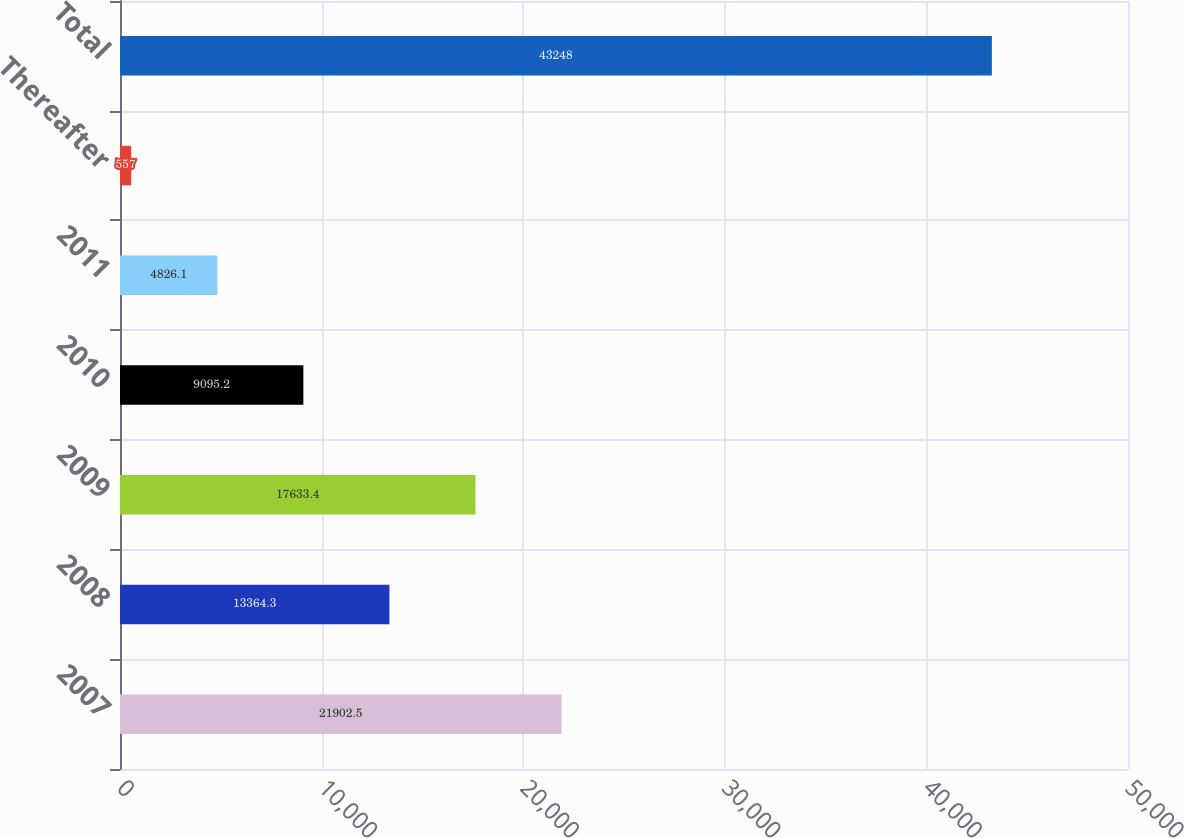<chart> <loc_0><loc_0><loc_500><loc_500><bar_chart><fcel>2007<fcel>2008<fcel>2009<fcel>2010<fcel>2011<fcel>Thereafter<fcel>Total<nl><fcel>21902.5<fcel>13364.3<fcel>17633.4<fcel>9095.2<fcel>4826.1<fcel>557<fcel>43248<nl></chart> 